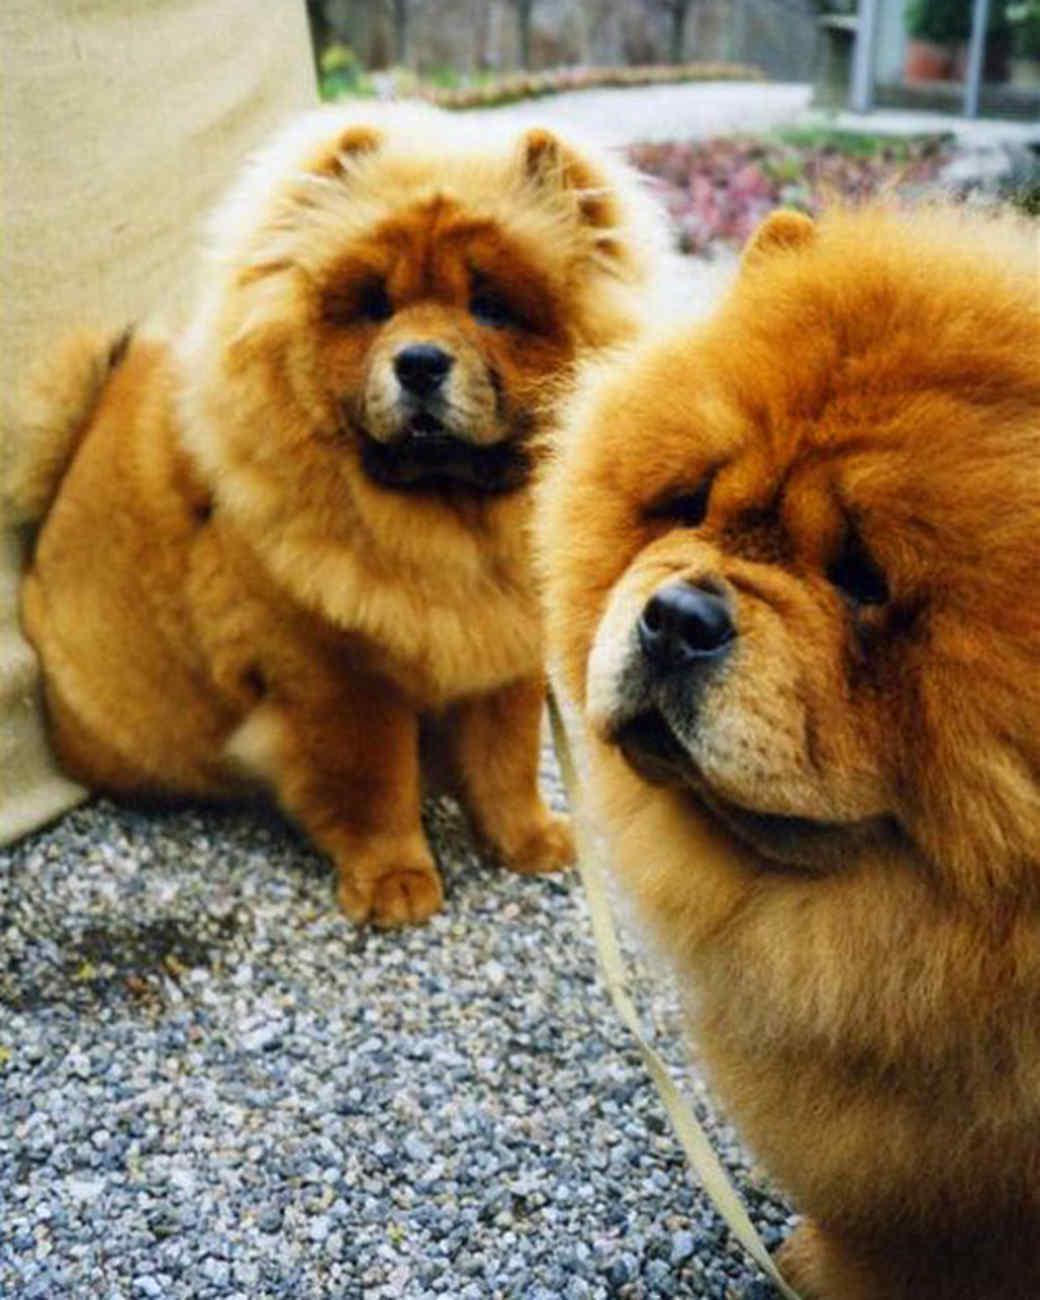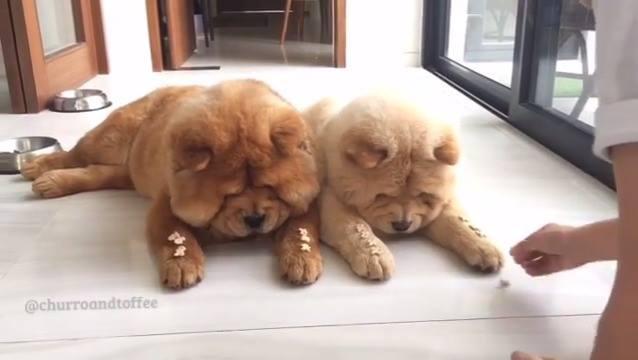The first image is the image on the left, the second image is the image on the right. Given the left and right images, does the statement "One of the dogs has something in its mouth." hold true? Answer yes or no. No. The first image is the image on the left, the second image is the image on the right. Analyze the images presented: Is the assertion "The image on the right has one dog with a toy in its mouth." valid? Answer yes or no. No. 